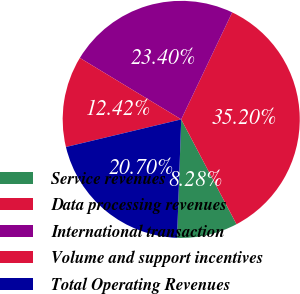Convert chart. <chart><loc_0><loc_0><loc_500><loc_500><pie_chart><fcel>Service revenues<fcel>Data processing revenues<fcel>International transaction<fcel>Volume and support incentives<fcel>Total Operating Revenues<nl><fcel>8.28%<fcel>35.2%<fcel>23.4%<fcel>12.42%<fcel>20.7%<nl></chart> 